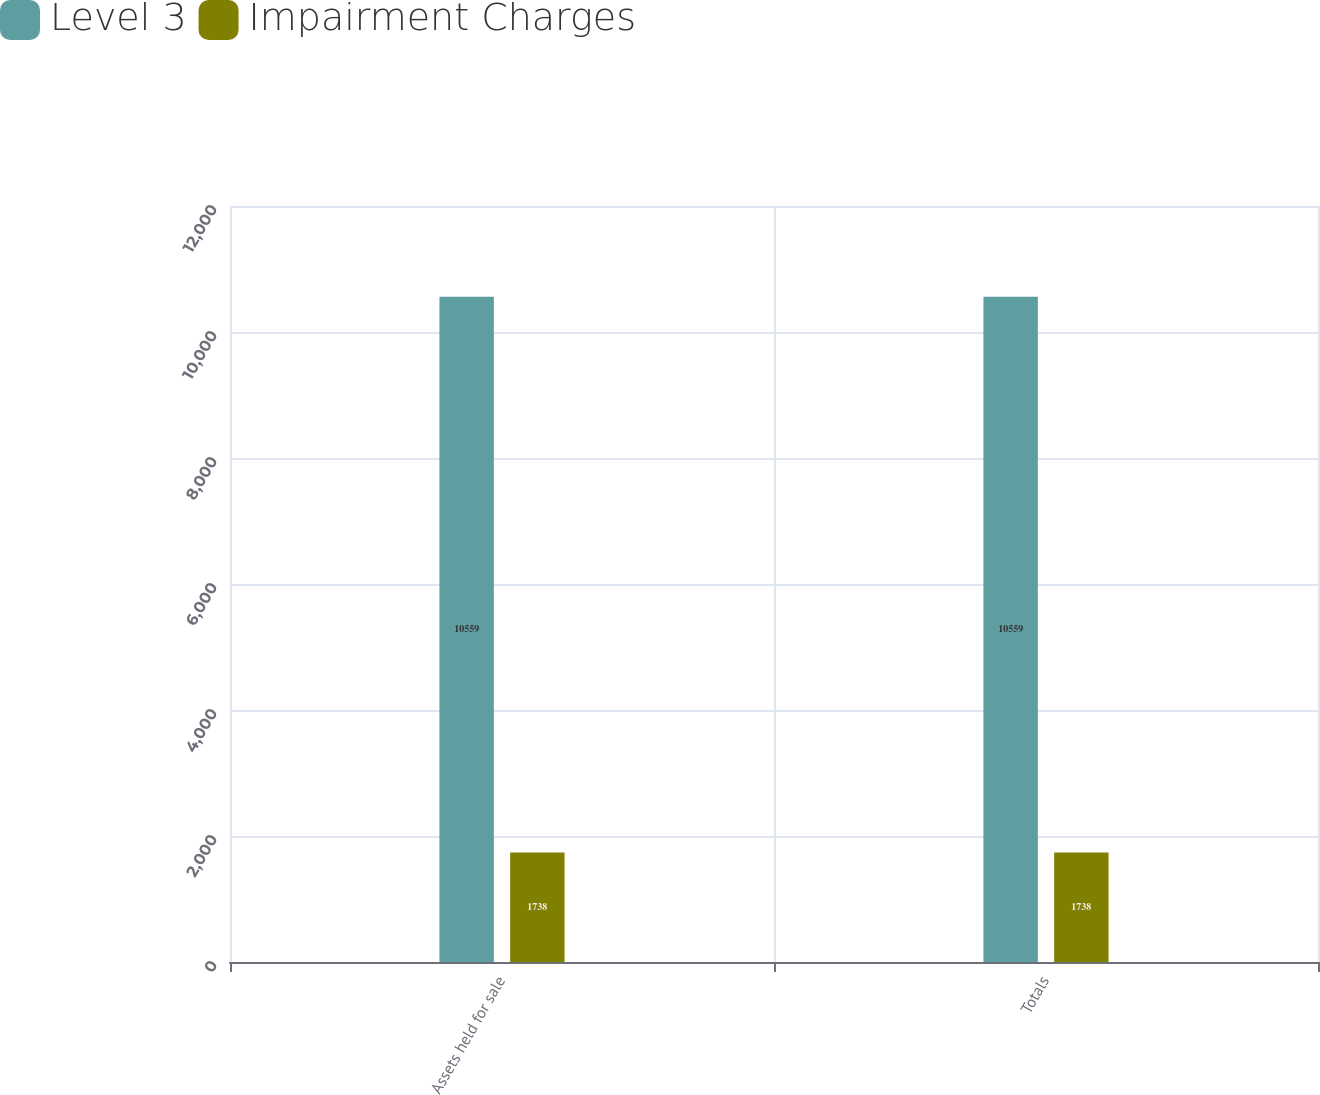Convert chart. <chart><loc_0><loc_0><loc_500><loc_500><stacked_bar_chart><ecel><fcel>Assets held for sale<fcel>Totals<nl><fcel>Level 3<fcel>10559<fcel>10559<nl><fcel>Impairment Charges<fcel>1738<fcel>1738<nl></chart> 